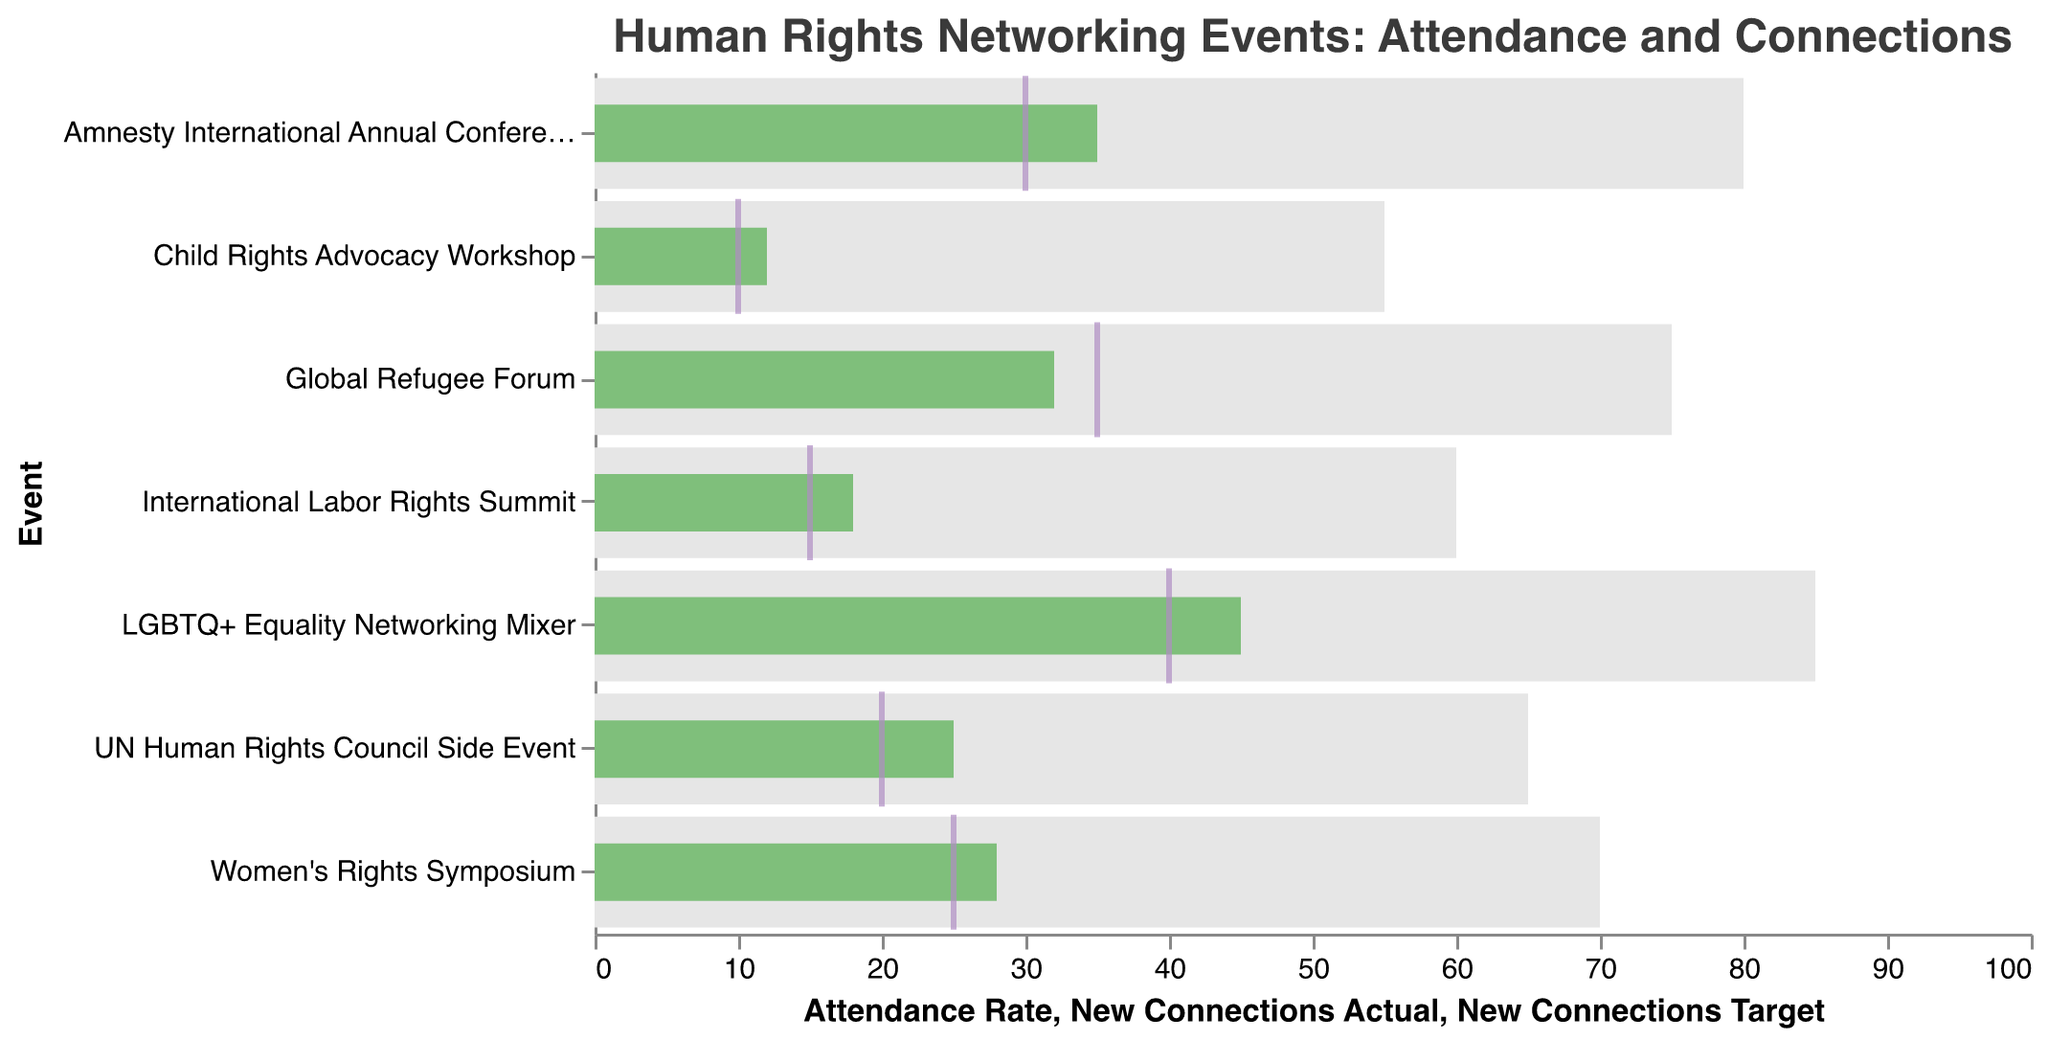What is the title of the chart? The title is displayed at the top of the chart and specifies the topic covered by the figure.
Answer: "Human Rights Networking Events: Attendance and Connections" Which event had the highest attendance rate? The event with the highest attendance rate will have the longest bar reaching the furthest on the x-axis.
Answer: LGBTQ+ Equality Networking Mixer How many new connections were made at the Women's Rights Symposium? The green bar for this event represents the actual number of new connections made.
Answer: 28 Did any event not meet its target for new connections? Compare the green bar (new connections actual) and the purple tick (new connections target) for each event to identify any differences.
Answer: Global Refugee Forum Which event had the lowest attendance rate? The event with the shortest bar on the x-axis represents the lowest attendance rate.
Answer: Child Rights Advocacy Workshop What is the difference between actual new connections and the target for the Amnesty International Annual Conference? Subtract the new connections target from the new connections actual for this event.
Answer: 5 (35 - 30) Compare the attendance rate of the Women's Rights Symposium and the International Labor Rights Summit. Look at the lengths of the bars for these two events on the x-axis to determine which is greater.
Answer: Women's Rights Symposium (70 vs. 60) Which event exceeded its target for new connections by the largest margin? Calculate the difference between the actual and target new connections for all events. The event with the largest positive difference is the answer.
Answer: LGBTQ+ Equality Networking Mixer (45 - 40 = 5) Did the UN Human Rights Council Side Event meet or exceed its target for new connections? Compare the green bar (new connections actual) to the purple tick (new connections target) for the event.
Answer: Exceeded What is the average attendance rate across all events? Sum the attendance rates for all events and divide by the number of events: (65 + 80 + 70 + 75 + 60 + 85 + 55) / 7
Answer: 70 